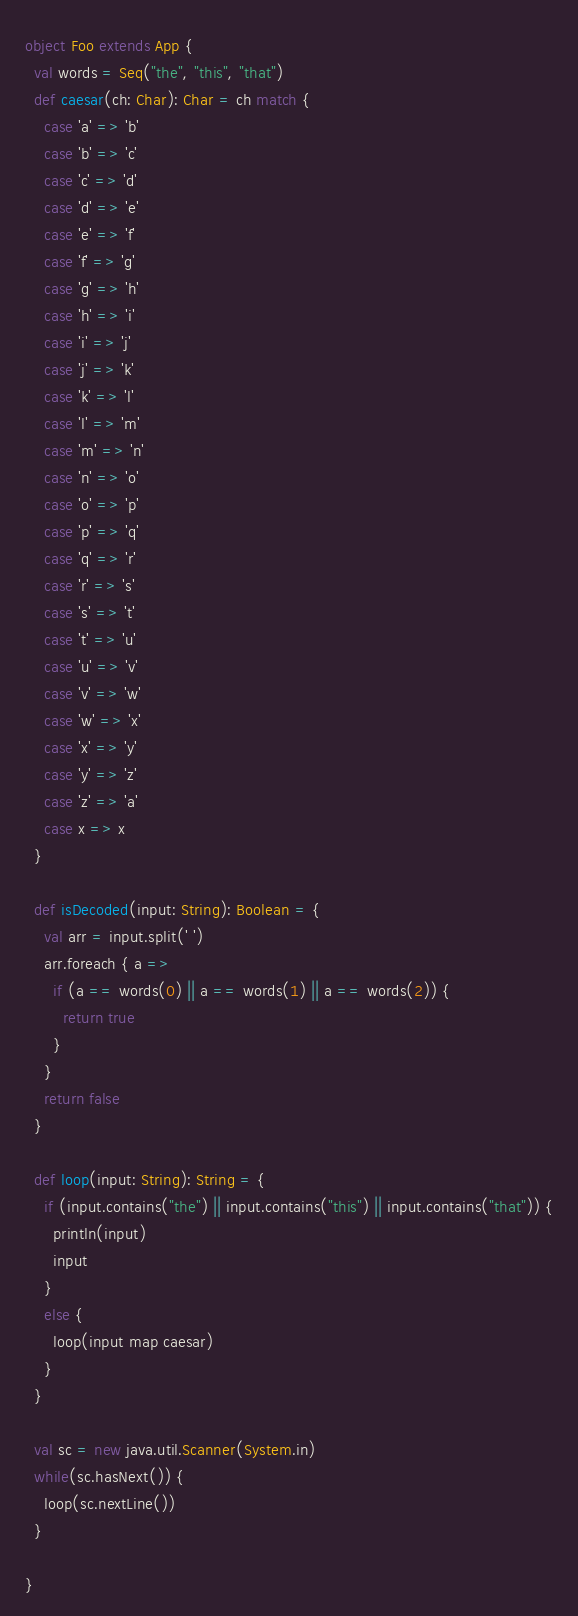<code> <loc_0><loc_0><loc_500><loc_500><_Scala_>object Foo extends App {
  val words = Seq("the", "this", "that")
  def caesar(ch: Char): Char = ch match {
    case 'a' => 'b'
    case 'b' => 'c'
    case 'c' => 'd'
    case 'd' => 'e'
    case 'e' => 'f'
    case 'f' => 'g'
    case 'g' => 'h'
    case 'h' => 'i'
    case 'i' => 'j'
    case 'j' => 'k'
    case 'k' => 'l'
    case 'l' => 'm'
    case 'm' => 'n'
    case 'n' => 'o'
    case 'o' => 'p'
    case 'p' => 'q'
    case 'q' => 'r'
    case 'r' => 's'
    case 's' => 't'
    case 't' => 'u'
    case 'u' => 'v'
    case 'v' => 'w'
    case 'w' => 'x'
    case 'x' => 'y'
    case 'y' => 'z'
    case 'z' => 'a'
    case x => x
  }

  def isDecoded(input: String): Boolean = {
    val arr = input.split(' ')
    arr.foreach { a =>
      if (a == words(0) || a == words(1) || a == words(2)) {
        return true
      }
    }
    return false
  }

  def loop(input: String): String = {
    if (input.contains("the") || input.contains("this") || input.contains("that")) {
      println(input)
      input
    }
    else {
      loop(input map caesar)
    }
  }

  val sc = new java.util.Scanner(System.in)
  while(sc.hasNext()) {
    loop(sc.nextLine())
  }

}</code> 